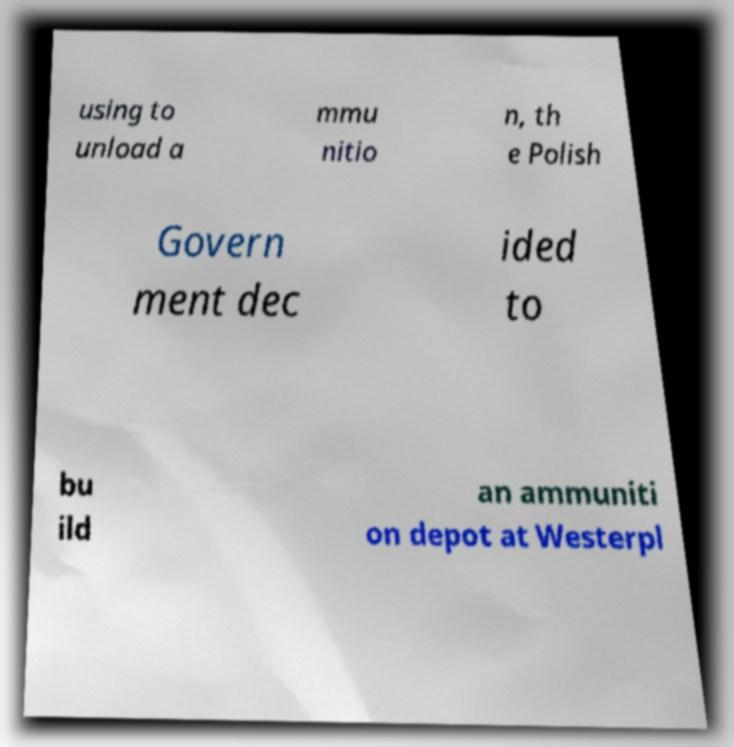Can you read and provide the text displayed in the image?This photo seems to have some interesting text. Can you extract and type it out for me? using to unload a mmu nitio n, th e Polish Govern ment dec ided to bu ild an ammuniti on depot at Westerpl 